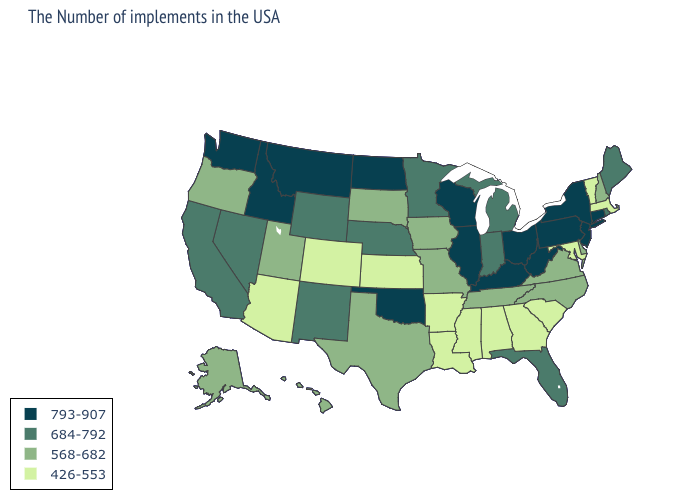Does California have the lowest value in the USA?
Write a very short answer. No. Does Idaho have the highest value in the USA?
Keep it brief. Yes. Name the states that have a value in the range 426-553?
Give a very brief answer. Massachusetts, Vermont, Maryland, South Carolina, Georgia, Alabama, Mississippi, Louisiana, Arkansas, Kansas, Colorado, Arizona. Does Ohio have the highest value in the USA?
Concise answer only. Yes. Name the states that have a value in the range 568-682?
Concise answer only. New Hampshire, Delaware, Virginia, North Carolina, Tennessee, Missouri, Iowa, Texas, South Dakota, Utah, Oregon, Alaska, Hawaii. What is the highest value in the USA?
Keep it brief. 793-907. What is the value of New Jersey?
Keep it brief. 793-907. Does Nevada have the lowest value in the USA?
Answer briefly. No. What is the value of Louisiana?
Quick response, please. 426-553. What is the lowest value in states that border South Dakota?
Concise answer only. 568-682. Among the states that border New York , does New Jersey have the highest value?
Give a very brief answer. Yes. Does Pennsylvania have the highest value in the Northeast?
Write a very short answer. Yes. Which states hav the highest value in the MidWest?
Write a very short answer. Ohio, Wisconsin, Illinois, North Dakota. Among the states that border West Virginia , does Kentucky have the highest value?
Answer briefly. Yes. Does Massachusetts have the lowest value in the USA?
Concise answer only. Yes. 